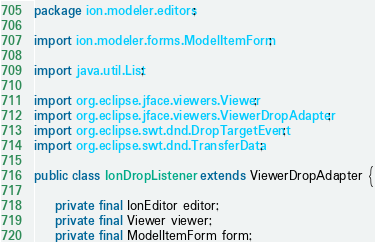Convert code to text. <code><loc_0><loc_0><loc_500><loc_500><_Java_>package ion.modeler.editors;

import ion.modeler.forms.ModelItemForm;

import java.util.List;

import org.eclipse.jface.viewers.Viewer;
import org.eclipse.jface.viewers.ViewerDropAdapter;
import org.eclipse.swt.dnd.DropTargetEvent;
import org.eclipse.swt.dnd.TransferData;

public class IonDropListener extends ViewerDropAdapter {

	private final IonEditor editor;
	private final Viewer viewer;
	private final ModelItemForm form;</code> 